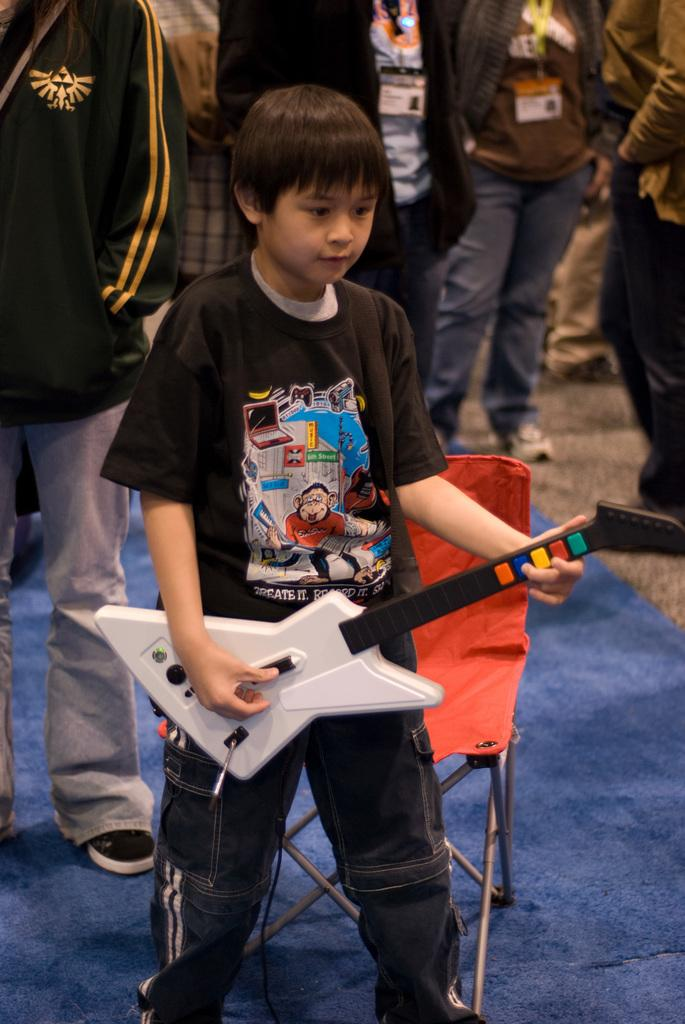Who is the main subject in the image? There is a boy in the image. What is the boy wearing? The boy is wearing a black t-shirt. What is the boy holding in the image? The boy is holding a guitar. What is the boy standing near? The boy is standing near a chair. What color is the carpet on which the chair is placed? The carpet is violet color. Can you describe the people in the background? There are other persons standing in the background. What type of thunder can be heard in the image? There is no sound present in the image, so it is not possible to determine if any thunder can be heard. 